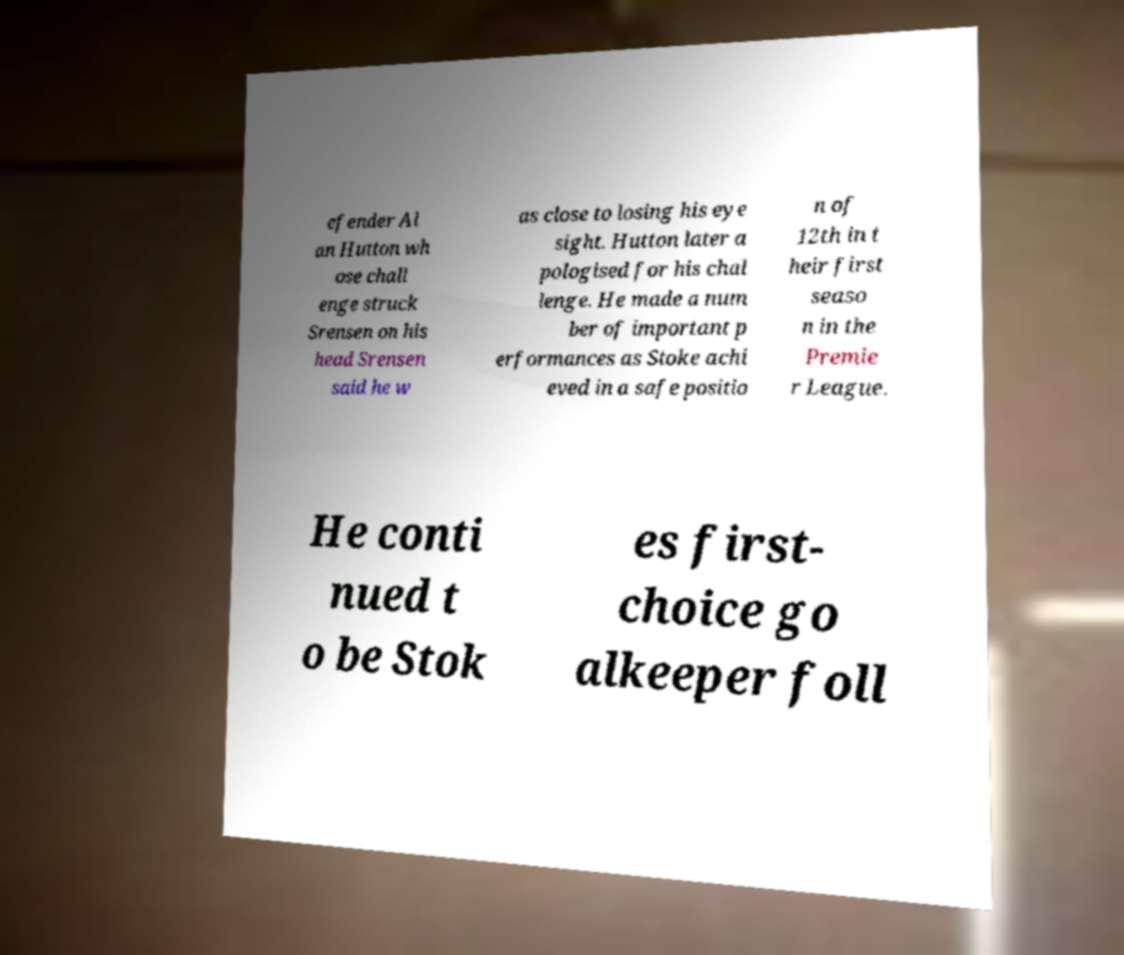For documentation purposes, I need the text within this image transcribed. Could you provide that? efender Al an Hutton wh ose chall enge struck Srensen on his head Srensen said he w as close to losing his eye sight. Hutton later a pologised for his chal lenge. He made a num ber of important p erformances as Stoke achi eved in a safe positio n of 12th in t heir first seaso n in the Premie r League. He conti nued t o be Stok es first- choice go alkeeper foll 